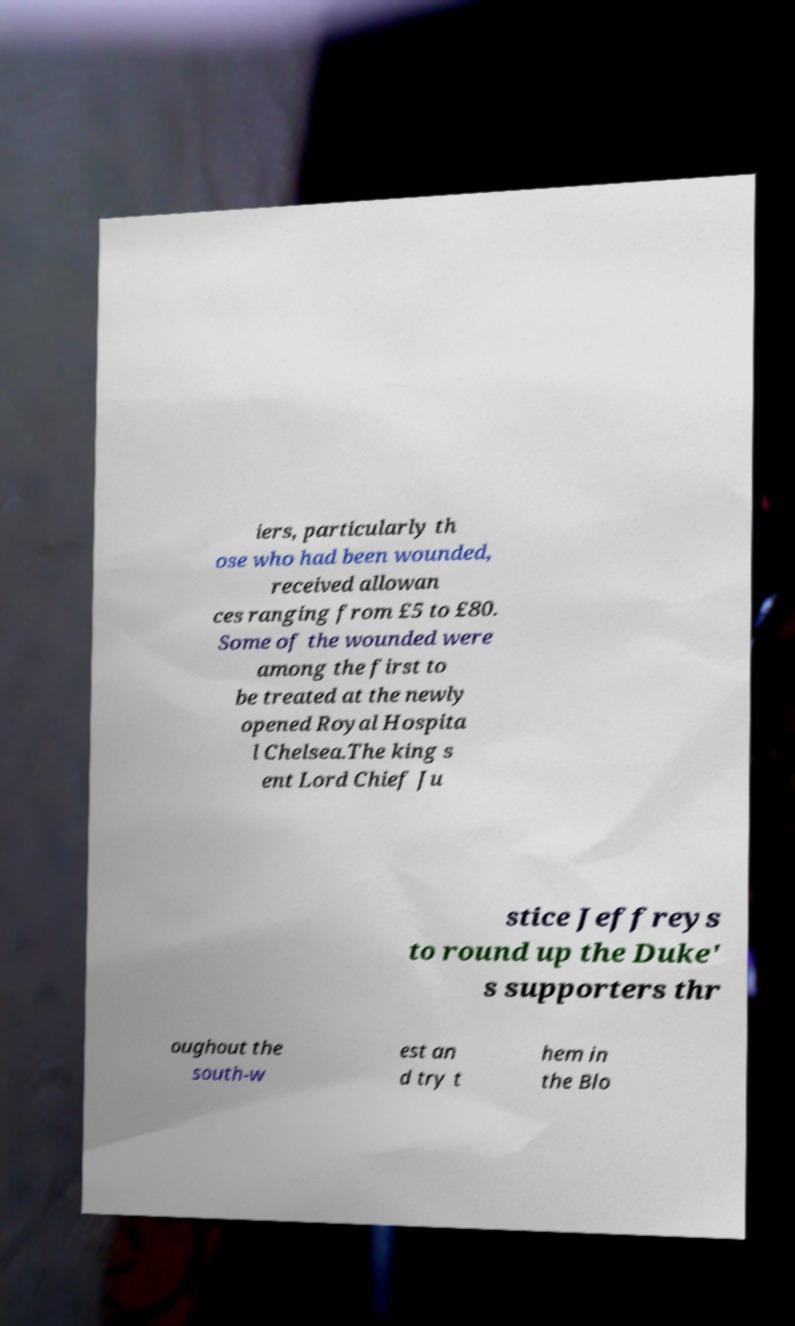Can you read and provide the text displayed in the image?This photo seems to have some interesting text. Can you extract and type it out for me? iers, particularly th ose who had been wounded, received allowan ces ranging from £5 to £80. Some of the wounded were among the first to be treated at the newly opened Royal Hospita l Chelsea.The king s ent Lord Chief Ju stice Jeffreys to round up the Duke' s supporters thr oughout the south-w est an d try t hem in the Blo 